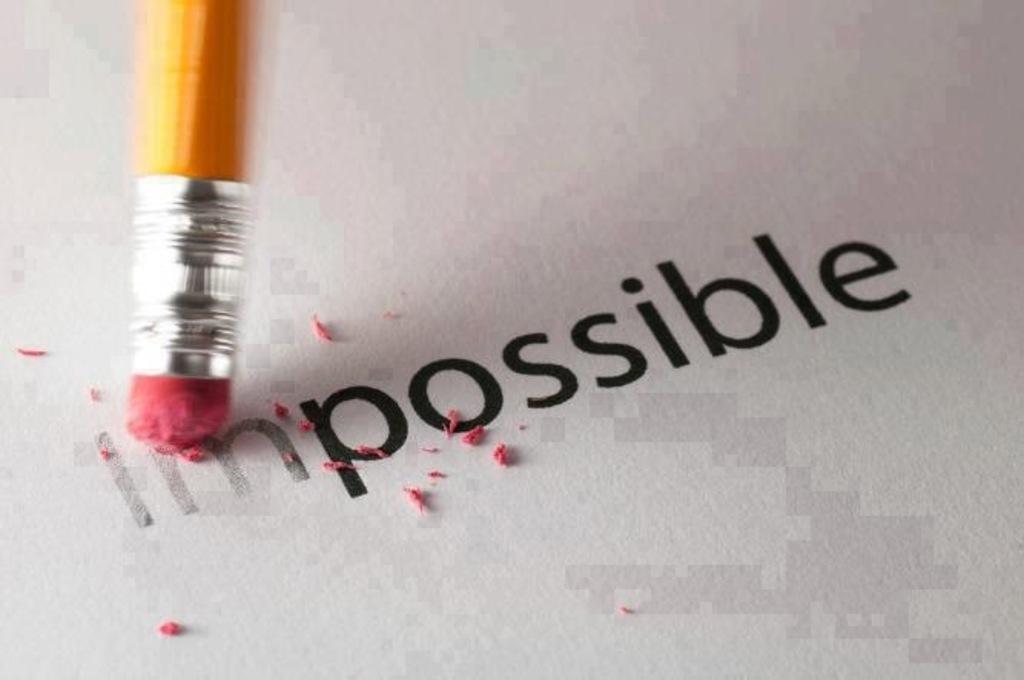Can you describe this image briefly? In this image we can see pencil and eraser on paper. 